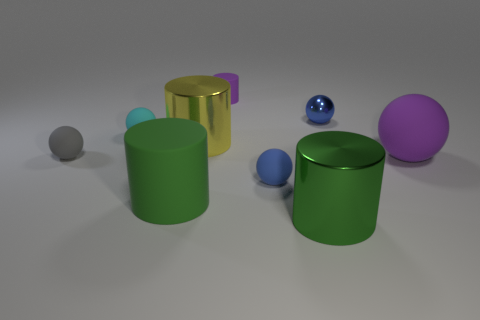The small matte thing that is both to the right of the green rubber cylinder and behind the big purple matte sphere has what shape?
Provide a succinct answer. Cylinder. Is there a green object that has the same material as the small gray sphere?
Make the answer very short. Yes. What material is the cylinder that is the same color as the big ball?
Offer a terse response. Rubber. Do the blue ball that is right of the big green metallic thing and the tiny blue sphere in front of the gray rubber thing have the same material?
Your answer should be very brief. No. Are there more large red cylinders than small gray rubber objects?
Make the answer very short. No. There is a matte cylinder on the left side of the purple rubber object that is left of the purple rubber thing that is in front of the small cyan matte ball; what is its color?
Your answer should be very brief. Green. There is a sphere that is behind the cyan thing; is it the same color as the large cylinder in front of the big green matte cylinder?
Offer a very short reply. No. How many green matte objects are behind the blue sphere that is in front of the tiny blue metallic object?
Provide a short and direct response. 0. Is there a small purple metal sphere?
Offer a terse response. No. How many other objects are there of the same color as the metallic ball?
Provide a succinct answer. 1. 